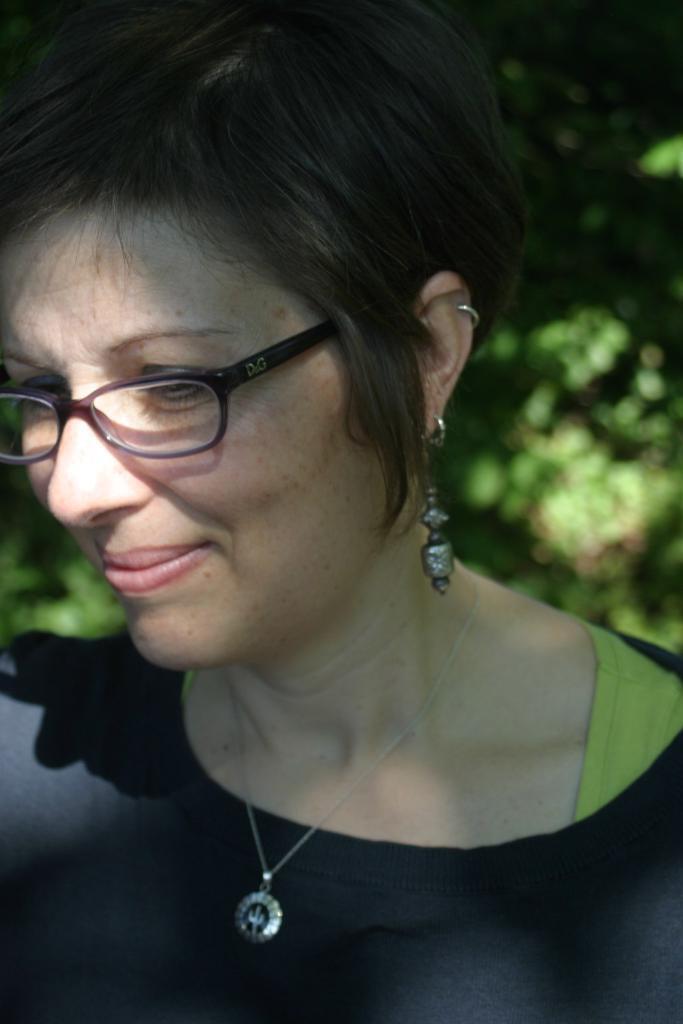In one or two sentences, can you explain what this image depicts? In this picture I can see there is a woman, she is smiling and wearing spectacles, a black dress, chain and ear rings and in the backdrop I can see there are plants. 